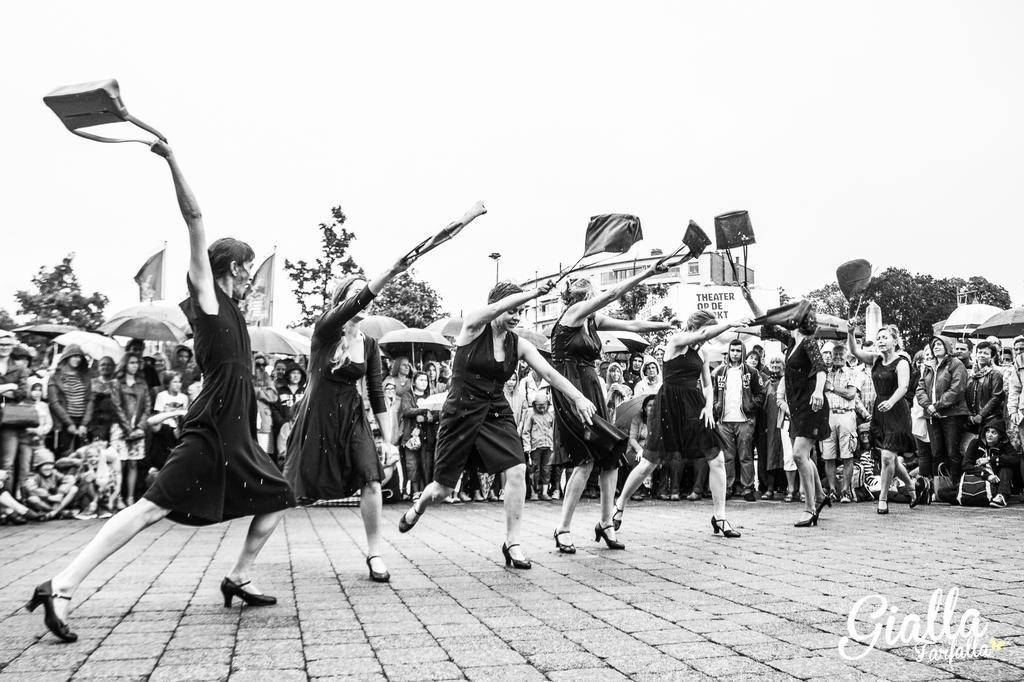Please provide a concise description of this image. It is a black and white image, there are few women dancing with handbags and around them there is a crowd and some of them are holding umbrellas, in the background there are trees. 